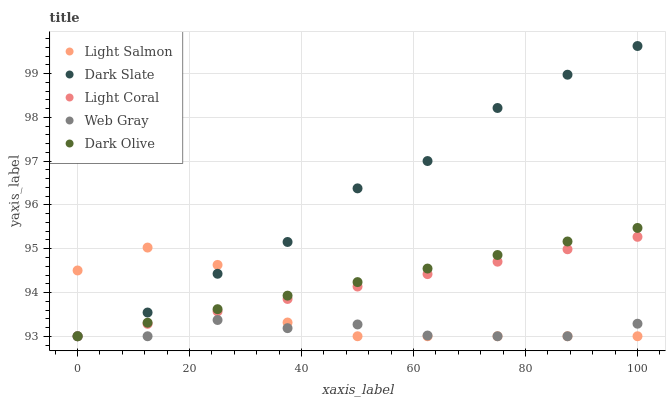Does Web Gray have the minimum area under the curve?
Answer yes or no. Yes. Does Dark Slate have the maximum area under the curve?
Answer yes or no. Yes. Does Light Salmon have the minimum area under the curve?
Answer yes or no. No. Does Light Salmon have the maximum area under the curve?
Answer yes or no. No. Is Light Coral the smoothest?
Answer yes or no. Yes. Is Light Salmon the roughest?
Answer yes or no. Yes. Is Dark Slate the smoothest?
Answer yes or no. No. Is Dark Slate the roughest?
Answer yes or no. No. Does Light Coral have the lowest value?
Answer yes or no. Yes. Does Dark Slate have the highest value?
Answer yes or no. Yes. Does Light Salmon have the highest value?
Answer yes or no. No. Does Dark Slate intersect Light Salmon?
Answer yes or no. Yes. Is Dark Slate less than Light Salmon?
Answer yes or no. No. Is Dark Slate greater than Light Salmon?
Answer yes or no. No. 